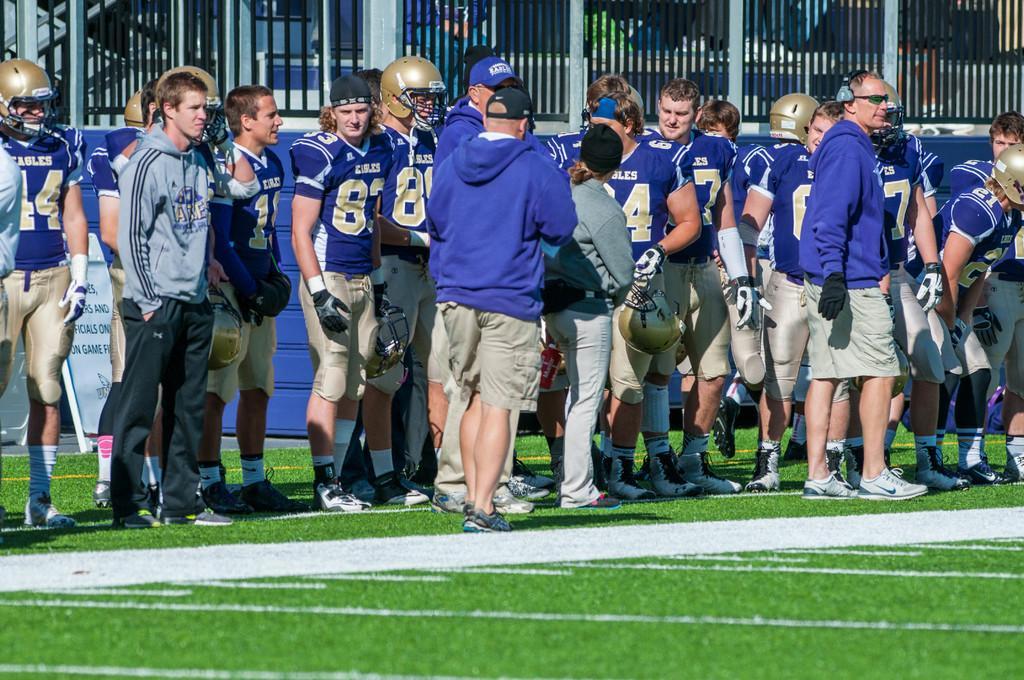Describe this image in one or two sentences. In this picture I can see group of people standing with helmets and gloves, this is looking like a board, and in the background there are iron grilles. 